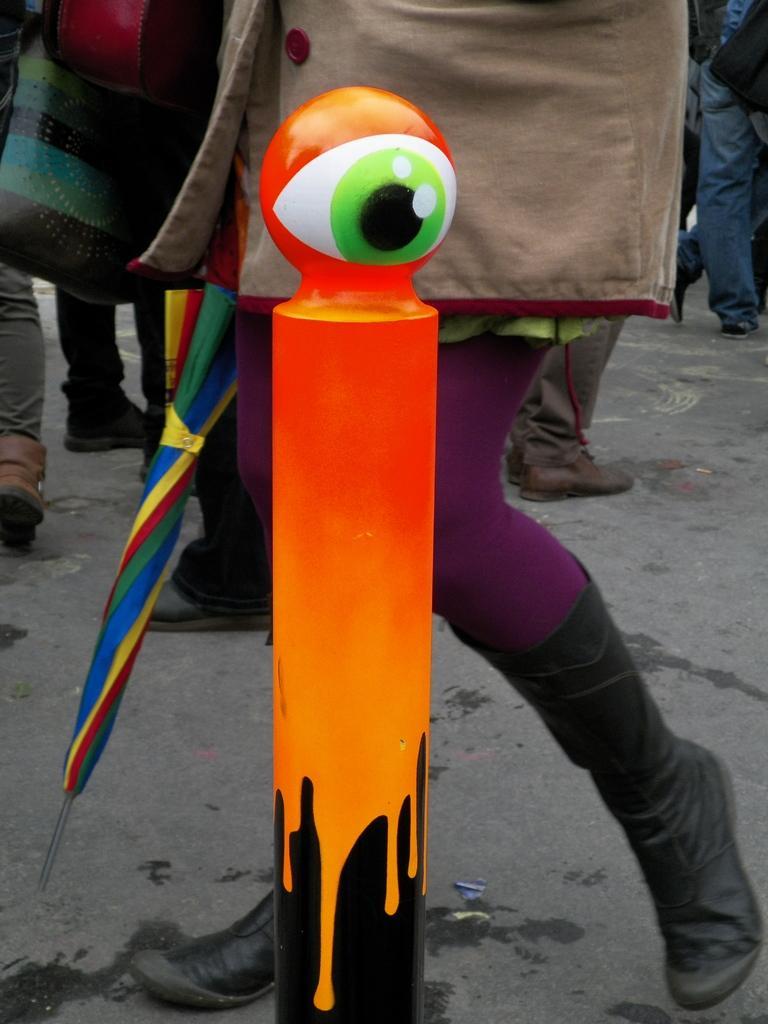How would you summarize this image in a sentence or two? In the center of the image we can see the painted rod. In the background we can see the people walking on the road. We can also see a person holding the umbrella and wearing the shoes. 